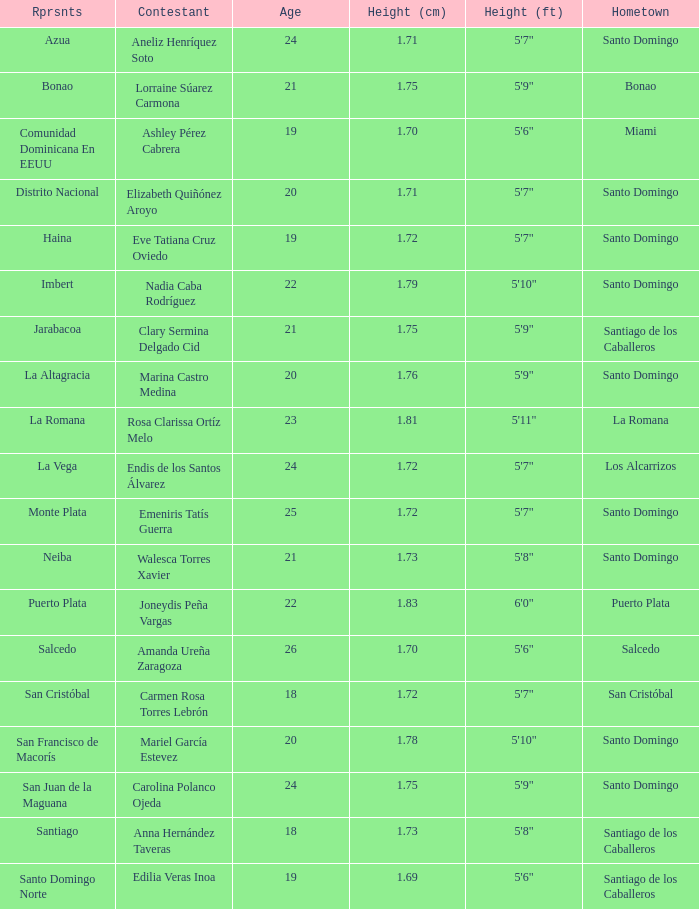Name the most age 26.0. 